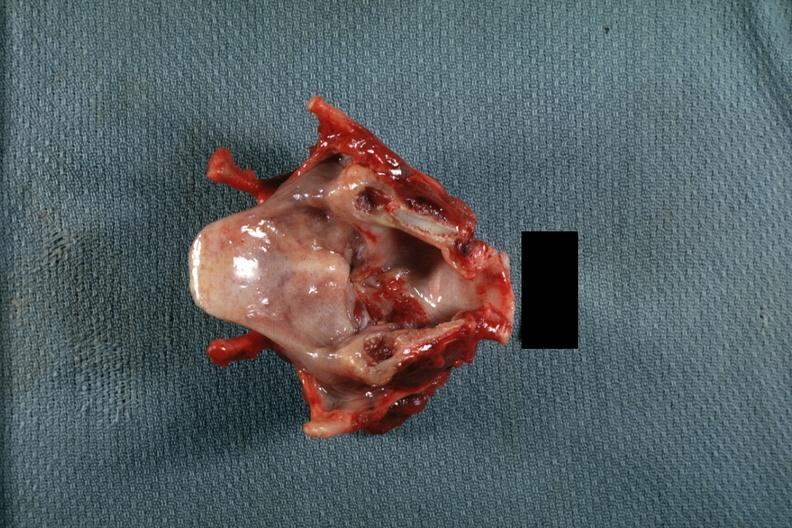what does this image show?
Answer the question using a single word or phrase. Excellent lesion on true cord spreading down 